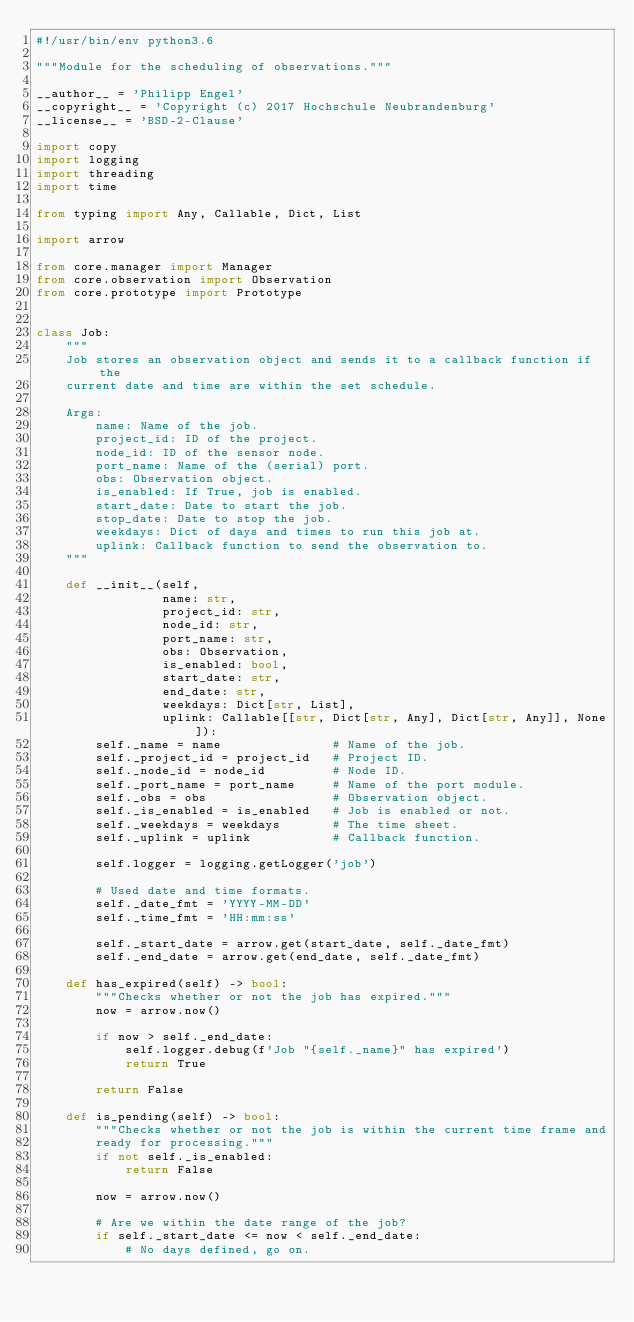<code> <loc_0><loc_0><loc_500><loc_500><_Python_>#!/usr/bin/env python3.6

"""Module for the scheduling of observations."""

__author__ = 'Philipp Engel'
__copyright__ = 'Copyright (c) 2017 Hochschule Neubrandenburg'
__license__ = 'BSD-2-Clause'

import copy
import logging
import threading
import time

from typing import Any, Callable, Dict, List

import arrow

from core.manager import Manager
from core.observation import Observation
from core.prototype import Prototype


class Job:
    """
    Job stores an observation object and sends it to a callback function if the
    current date and time are within the set schedule.

    Args:
        name: Name of the job.
        project_id: ID of the project.
        node_id: ID of the sensor node.
        port_name: Name of the (serial) port.
        obs: Observation object.
        is_enabled: If True, job is enabled.
        start_date: Date to start the job.
        stop_date: Date to stop the job.
        weekdays: Dict of days and times to run this job at.
        uplink: Callback function to send the observation to.
    """

    def __init__(self,
                 name: str,
                 project_id: str,
                 node_id: str,
                 port_name: str,
                 obs: Observation,
                 is_enabled: bool,
                 start_date: str,
                 end_date: str,
                 weekdays: Dict[str, List],
                 uplink: Callable[[str, Dict[str, Any], Dict[str, Any]], None]):
        self._name = name               # Name of the job.
        self._project_id = project_id   # Project ID.
        self._node_id = node_id         # Node ID.
        self._port_name = port_name     # Name of the port module.
        self._obs = obs                 # Observation object.
        self._is_enabled = is_enabled   # Job is enabled or not.
        self._weekdays = weekdays       # The time sheet.
        self._uplink = uplink           # Callback function.

        self.logger = logging.getLogger('job')

        # Used date and time formats.
        self._date_fmt = 'YYYY-MM-DD'
        self._time_fmt = 'HH:mm:ss'

        self._start_date = arrow.get(start_date, self._date_fmt)
        self._end_date = arrow.get(end_date, self._date_fmt)

    def has_expired(self) -> bool:
        """Checks whether or not the job has expired."""
        now = arrow.now()

        if now > self._end_date:
            self.logger.debug(f'Job "{self._name}" has expired')
            return True

        return False

    def is_pending(self) -> bool:
        """Checks whether or not the job is within the current time frame and
        ready for processing."""
        if not self._is_enabled:
            return False

        now = arrow.now()

        # Are we within the date range of the job?
        if self._start_date <= now < self._end_date:
            # No days defined, go on.</code> 